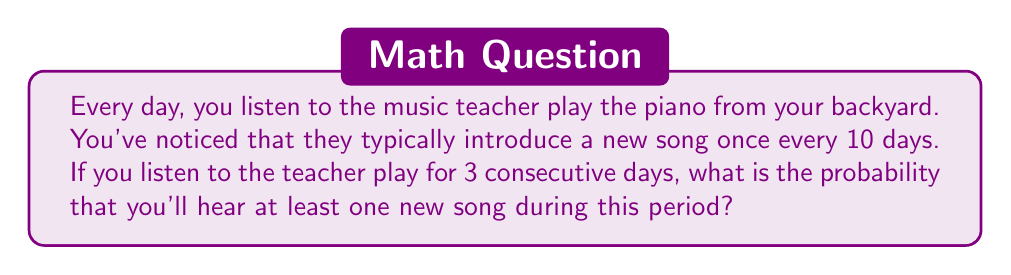Provide a solution to this math problem. Let's approach this step-by-step:

1) First, let's calculate the probability of hearing a new song on any given day:
   $P(\text{new song on one day}) = \frac{1}{10} = 0.1$

2) The probability of not hearing a new song on a given day is:
   $P(\text{no new song on one day}) = 1 - 0.1 = 0.9$

3) For three consecutive days, the probability of not hearing any new song is:
   $P(\text{no new song in 3 days}) = 0.9 \times 0.9 \times 0.9 = 0.9^3 = 0.729$

4) Therefore, the probability of hearing at least one new song in 3 days is the complement of hearing no new songs:
   $P(\text{at least one new song in 3 days}) = 1 - P(\text{no new song in 3 days})$
   $= 1 - 0.729 = 0.271$

5) Converting to a percentage:
   $0.271 \times 100\% = 27.1\%$
Answer: 27.1% 